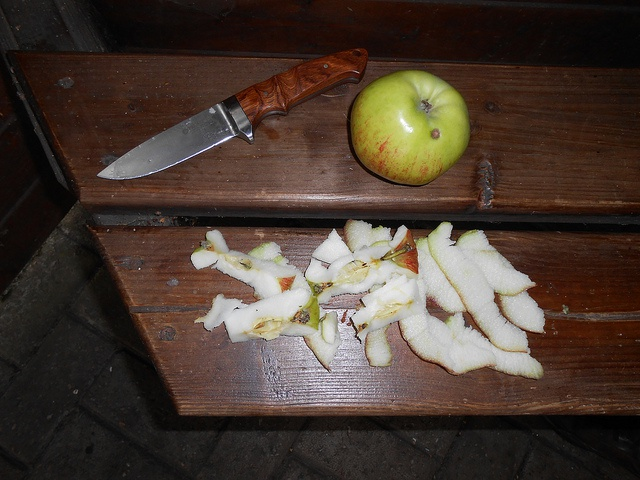Describe the objects in this image and their specific colors. I can see dining table in black, maroon, gray, and lightgray tones, apple in black, lightgray, darkgray, and tan tones, apple in black, khaki, and olive tones, and knife in black, maroon, and gray tones in this image. 